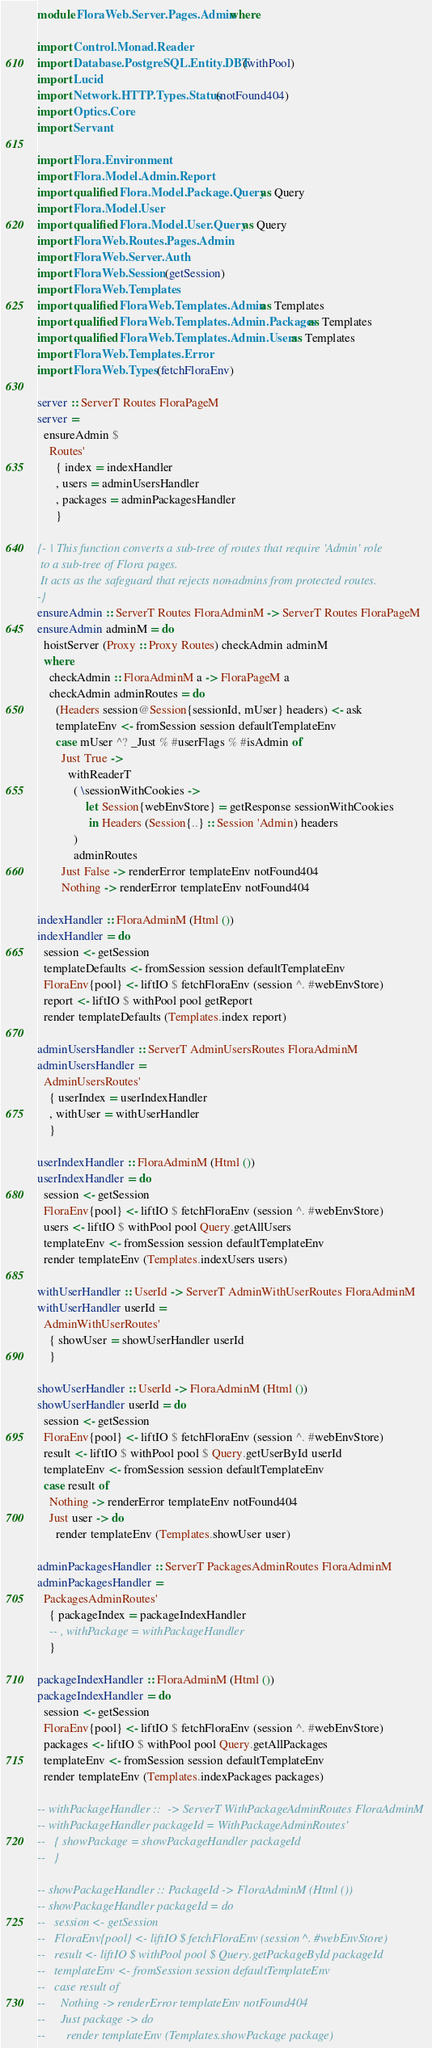<code> <loc_0><loc_0><loc_500><loc_500><_Haskell_>module FloraWeb.Server.Pages.Admin where

import Control.Monad.Reader
import Database.PostgreSQL.Entity.DBT (withPool)
import Lucid
import Network.HTTP.Types.Status (notFound404)
import Optics.Core
import Servant

import Flora.Environment
import Flora.Model.Admin.Report
import qualified Flora.Model.Package.Query as Query
import Flora.Model.User
import qualified Flora.Model.User.Query as Query
import FloraWeb.Routes.Pages.Admin
import FloraWeb.Server.Auth
import FloraWeb.Session (getSession)
import FloraWeb.Templates
import qualified FloraWeb.Templates.Admin as Templates
import qualified FloraWeb.Templates.Admin.Packages as Templates
import qualified FloraWeb.Templates.Admin.Users as Templates
import FloraWeb.Templates.Error
import FloraWeb.Types (fetchFloraEnv)

server :: ServerT Routes FloraPageM
server =
  ensureAdmin $
    Routes'
      { index = indexHandler
      , users = adminUsersHandler
      , packages = adminPackagesHandler
      }

{- | This function converts a sub-tree of routes that require 'Admin' role
 to a sub-tree of Flora pages.
 It acts as the safeguard that rejects non-admins from protected routes.
-}
ensureAdmin :: ServerT Routes FloraAdminM -> ServerT Routes FloraPageM
ensureAdmin adminM = do
  hoistServer (Proxy :: Proxy Routes) checkAdmin adminM
  where
    checkAdmin :: FloraAdminM a -> FloraPageM a
    checkAdmin adminRoutes = do
      (Headers session@Session{sessionId, mUser} headers) <- ask
      templateEnv <- fromSession session defaultTemplateEnv
      case mUser ^? _Just % #userFlags % #isAdmin of
        Just True ->
          withReaderT
            ( \sessionWithCookies ->
                let Session{webEnvStore} = getResponse sessionWithCookies
                 in Headers (Session{..} :: Session 'Admin) headers
            )
            adminRoutes
        Just False -> renderError templateEnv notFound404
        Nothing -> renderError templateEnv notFound404

indexHandler :: FloraAdminM (Html ())
indexHandler = do
  session <- getSession
  templateDefaults <- fromSession session defaultTemplateEnv
  FloraEnv{pool} <- liftIO $ fetchFloraEnv (session ^. #webEnvStore)
  report <- liftIO $ withPool pool getReport
  render templateDefaults (Templates.index report)

adminUsersHandler :: ServerT AdminUsersRoutes FloraAdminM
adminUsersHandler =
  AdminUsersRoutes'
    { userIndex = userIndexHandler
    , withUser = withUserHandler
    }

userIndexHandler :: FloraAdminM (Html ())
userIndexHandler = do
  session <- getSession
  FloraEnv{pool} <- liftIO $ fetchFloraEnv (session ^. #webEnvStore)
  users <- liftIO $ withPool pool Query.getAllUsers
  templateEnv <- fromSession session defaultTemplateEnv
  render templateEnv (Templates.indexUsers users)

withUserHandler :: UserId -> ServerT AdminWithUserRoutes FloraAdminM
withUserHandler userId =
  AdminWithUserRoutes'
    { showUser = showUserHandler userId
    }

showUserHandler :: UserId -> FloraAdminM (Html ())
showUserHandler userId = do
  session <- getSession
  FloraEnv{pool} <- liftIO $ fetchFloraEnv (session ^. #webEnvStore)
  result <- liftIO $ withPool pool $ Query.getUserById userId
  templateEnv <- fromSession session defaultTemplateEnv
  case result of
    Nothing -> renderError templateEnv notFound404
    Just user -> do
      render templateEnv (Templates.showUser user)

adminPackagesHandler :: ServerT PackagesAdminRoutes FloraAdminM
adminPackagesHandler =
  PackagesAdminRoutes'
    { packageIndex = packageIndexHandler
    -- , withPackage = withPackageHandler
    }

packageIndexHandler :: FloraAdminM (Html ())
packageIndexHandler = do
  session <- getSession
  FloraEnv{pool} <- liftIO $ fetchFloraEnv (session ^. #webEnvStore)
  packages <- liftIO $ withPool pool Query.getAllPackages
  templateEnv <- fromSession session defaultTemplateEnv
  render templateEnv (Templates.indexPackages packages)

-- withPackageHandler ::  -> ServerT WithPackageAdminRoutes FloraAdminM
-- withPackageHandler packageId = WithPackageAdminRoutes'
--   { showPackage = showPackageHandler packageId
--   }

-- showPackageHandler :: PackageId -> FloraAdminM (Html ())
-- showPackageHandler packageId = do
--   session <- getSession
--   FloraEnv{pool} <- liftIO $ fetchFloraEnv (session ^. #webEnvStore)
--   result <- liftIO $ withPool pool $ Query.getPackageById packageId
--   templateEnv <- fromSession session defaultTemplateEnv
--   case result of
--     Nothing -> renderError templateEnv notFound404
--     Just package -> do
--       render templateEnv (Templates.showPackage package)
</code> 